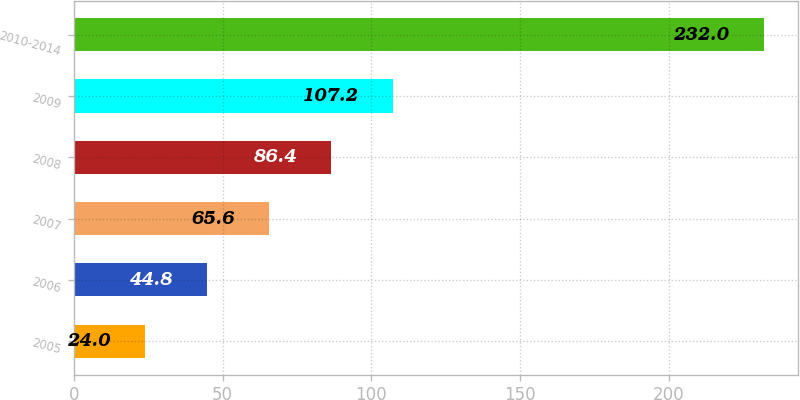Convert chart to OTSL. <chart><loc_0><loc_0><loc_500><loc_500><bar_chart><fcel>2005<fcel>2006<fcel>2007<fcel>2008<fcel>2009<fcel>2010-2014<nl><fcel>24<fcel>44.8<fcel>65.6<fcel>86.4<fcel>107.2<fcel>232<nl></chart> 